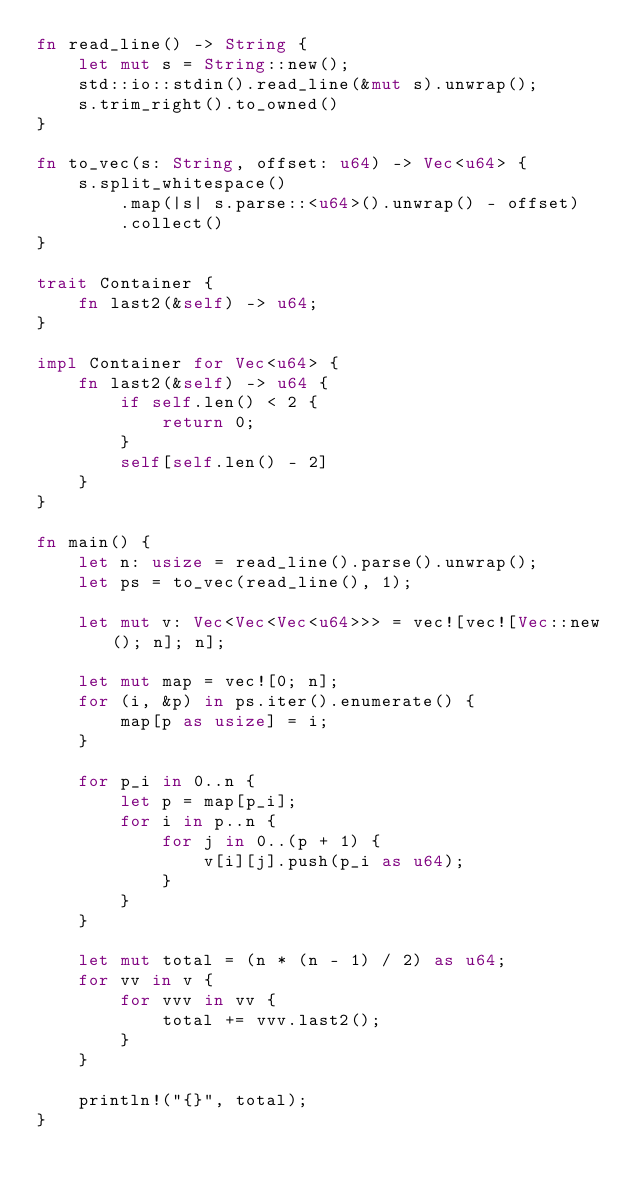Convert code to text. <code><loc_0><loc_0><loc_500><loc_500><_Rust_>fn read_line() -> String {
    let mut s = String::new();
    std::io::stdin().read_line(&mut s).unwrap();
    s.trim_right().to_owned()
}

fn to_vec(s: String, offset: u64) -> Vec<u64> {
    s.split_whitespace()
        .map(|s| s.parse::<u64>().unwrap() - offset)
        .collect()
}

trait Container {
    fn last2(&self) -> u64;
}

impl Container for Vec<u64> {
    fn last2(&self) -> u64 {
        if self.len() < 2 {
            return 0;
        }
        self[self.len() - 2]
    }
}

fn main() {
    let n: usize = read_line().parse().unwrap();
    let ps = to_vec(read_line(), 1);

    let mut v: Vec<Vec<Vec<u64>>> = vec![vec![Vec::new(); n]; n];

    let mut map = vec![0; n];
    for (i, &p) in ps.iter().enumerate() {
        map[p as usize] = i;
    }

    for p_i in 0..n {
        let p = map[p_i];
        for i in p..n {
            for j in 0..(p + 1) {
                v[i][j].push(p_i as u64);
            }
        }
    }

    let mut total = (n * (n - 1) / 2) as u64;
    for vv in v {
        for vvv in vv {
            total += vvv.last2();
        }
    }

    println!("{}", total);
}
</code> 